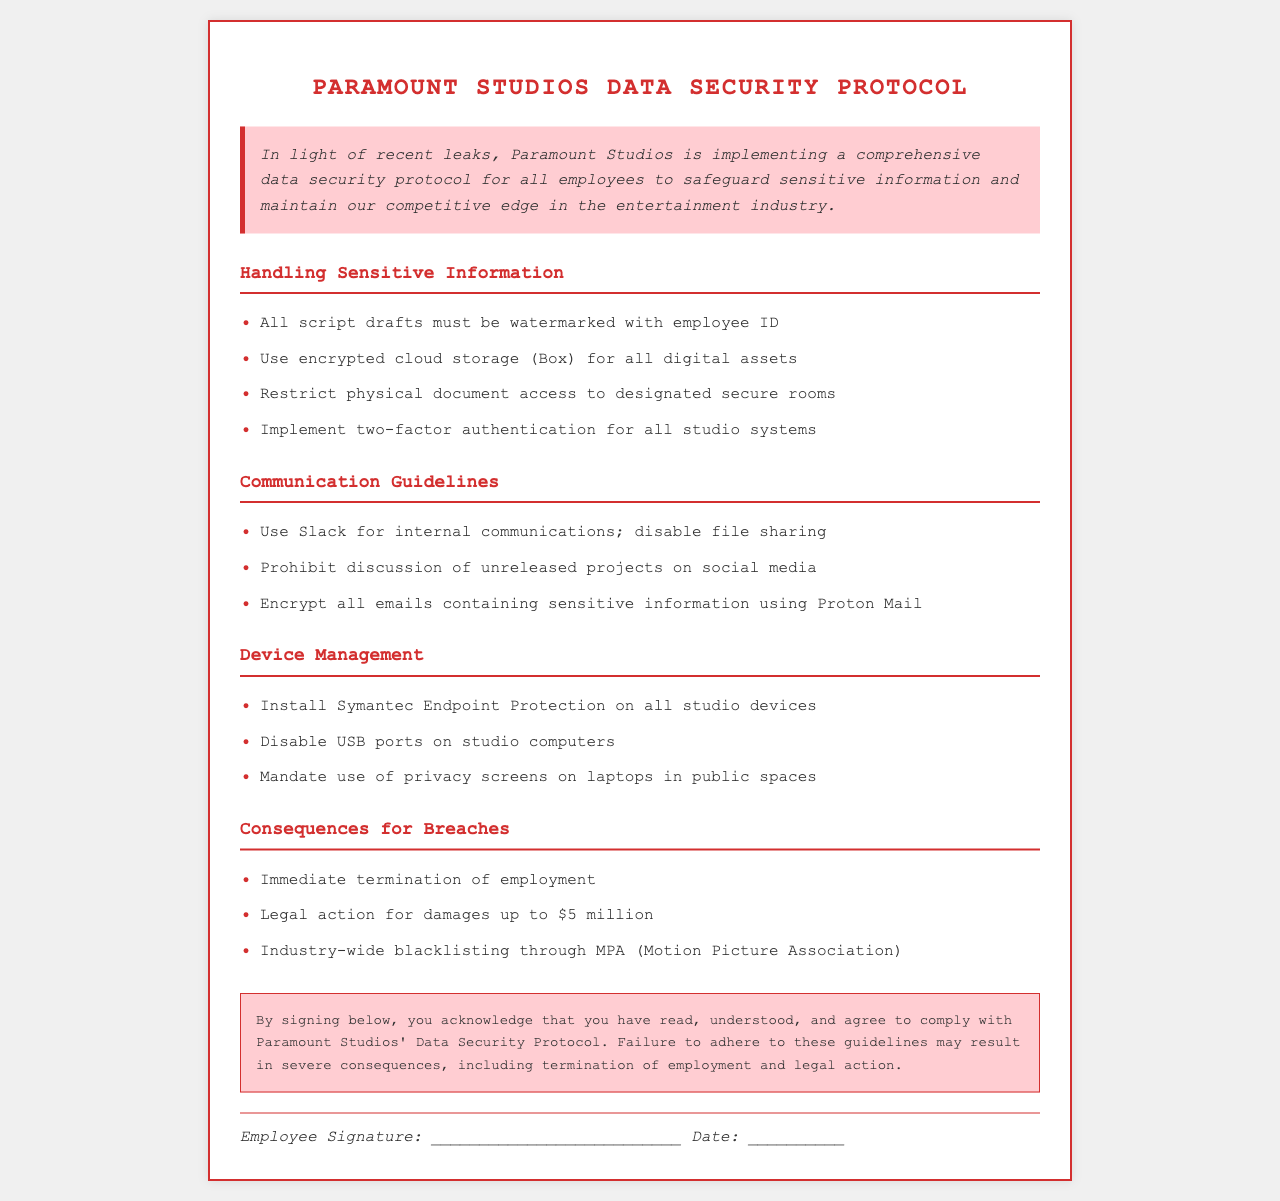what is the title of the protocol? The title of the document indicates the main subject being addressed, which is data security specific to Paramount Studios.
Answer: Paramount Studios Data Security Protocol what is the first guideline for handling sensitive information? The first item under handling sensitive information specifies a requirement for all script drafts, indicating a proactive approach to data protection.
Answer: All script drafts must be watermarked with employee ID which platform is designated for internal communications? Identifying the platform for internal communications helps to ensure compliance with the guidelines provided in the document.
Answer: Slack what is the consequence for a breach of the data security protocol? Understanding the consequences provides clear accountability and seriousness regarding adherence to the protocol.
Answer: Immediate termination of employment how much legal damages can be claimed for breaches? This figure highlights the severe financial repercussions that breaches can incur, indicating the importance of following the protocol.
Answer: $5 million what is required for accessing studio systems? This requirement establishes a security measure that is necessary for protecting sensitive information from unauthorized access.
Answer: Two-factor authentication what should be disabled on studio computers? This specification is aimed at limiting the vulnerabilities of studio devices, which are essential in maintaining data security.
Answer: USB ports how should sensitive emails be sent? This directive ensures that sensitive communications are protected, thereby minimizing the risk of information leaks.
Answer: Encrypt all emails containing sensitive information using Proton Mail which security software must be installed on studio devices? Knowing the security software in use outlines the technical measures in place to protect the studio's information resources.
Answer: Symantec Endpoint Protection 